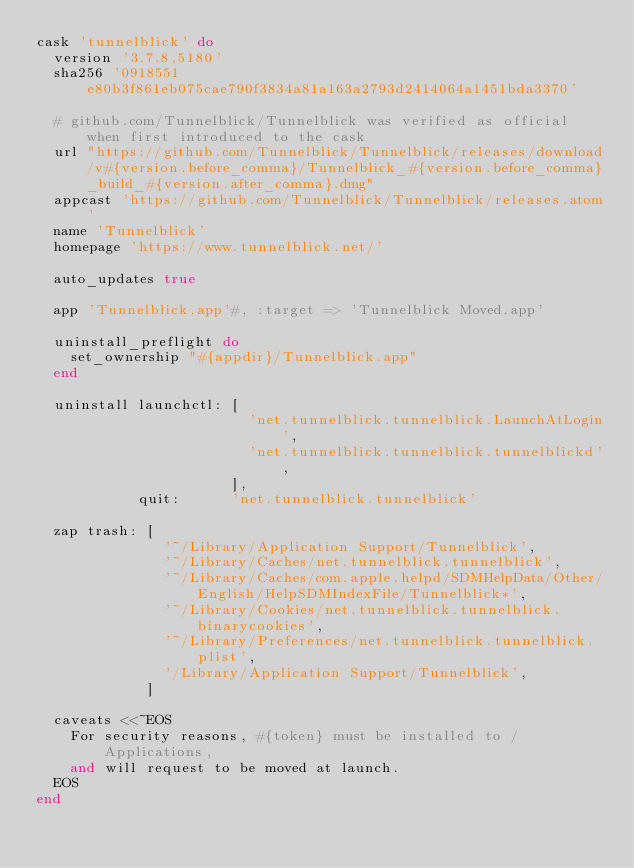<code> <loc_0><loc_0><loc_500><loc_500><_Ruby_>cask 'tunnelblick' do
  version '3.7.8,5180'
  sha256 '0918551e80b3f861eb075cae790f3834a81a163a2793d2414064a1451bda3370'

  # github.com/Tunnelblick/Tunnelblick was verified as official when first introduced to the cask
  url "https://github.com/Tunnelblick/Tunnelblick/releases/download/v#{version.before_comma}/Tunnelblick_#{version.before_comma}_build_#{version.after_comma}.dmg"
  appcast 'https://github.com/Tunnelblick/Tunnelblick/releases.atom'
  name 'Tunnelblick'
  homepage 'https://www.tunnelblick.net/'

  auto_updates true

  app 'Tunnelblick.app'#, :target => 'Tunnelblick Moved.app'

  uninstall_preflight do
    set_ownership "#{appdir}/Tunnelblick.app"
  end

  uninstall launchctl: [
                         'net.tunnelblick.tunnelblick.LaunchAtLogin',
                         'net.tunnelblick.tunnelblick.tunnelblickd',
                       ],
            quit:      'net.tunnelblick.tunnelblick'

  zap trash: [
               '~/Library/Application Support/Tunnelblick',
               '~/Library/Caches/net.tunnelblick.tunnelblick',
               '~/Library/Caches/com.apple.helpd/SDMHelpData/Other/English/HelpSDMIndexFile/Tunnelblick*',
               '~/Library/Cookies/net.tunnelblick.tunnelblick.binarycookies',
               '~/Library/Preferences/net.tunnelblick.tunnelblick.plist',
               '/Library/Application Support/Tunnelblick',
             ]

  caveats <<~EOS
    For security reasons, #{token} must be installed to /Applications,
    and will request to be moved at launch.
  EOS
end
</code> 